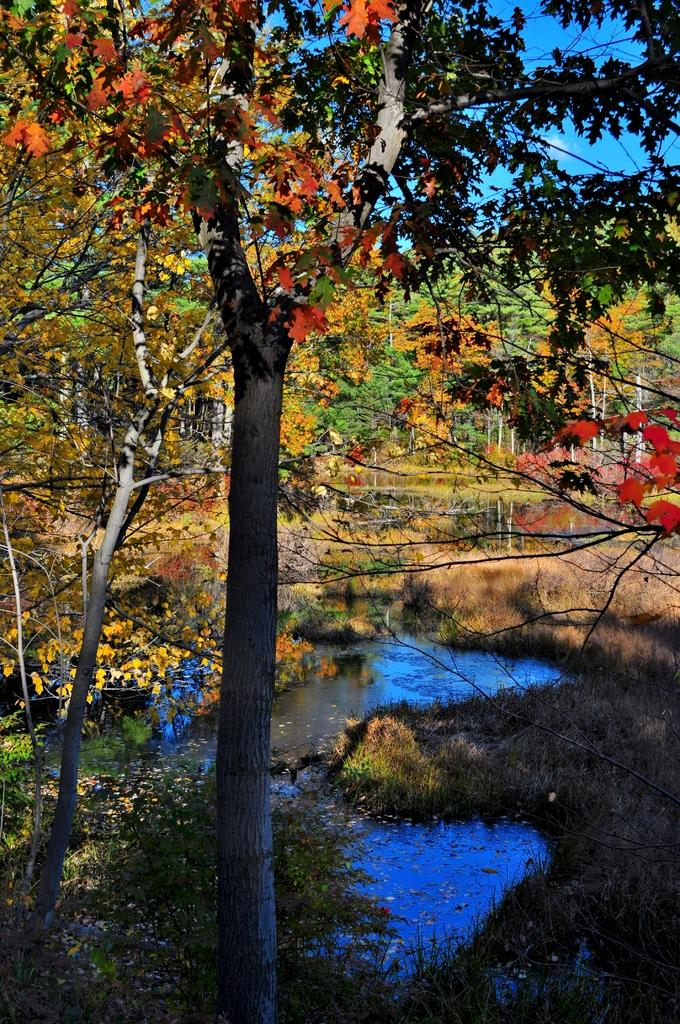What type of vegetation can be seen in the front of the image? There are trees in the front of the image. What is located in the center of the image? There is water in the center of the image. What type of vegetation can be seen in the background of the image? There are trees in the background of the image. What type of ground cover is present in the image? There is grass on the ground in the image. What type of frame is visible around the image? There is no frame visible around the image; the image is not framed. What way can the water be controlled in the image? The image does not depict any means of controlling the water; it is a natural body of water. 